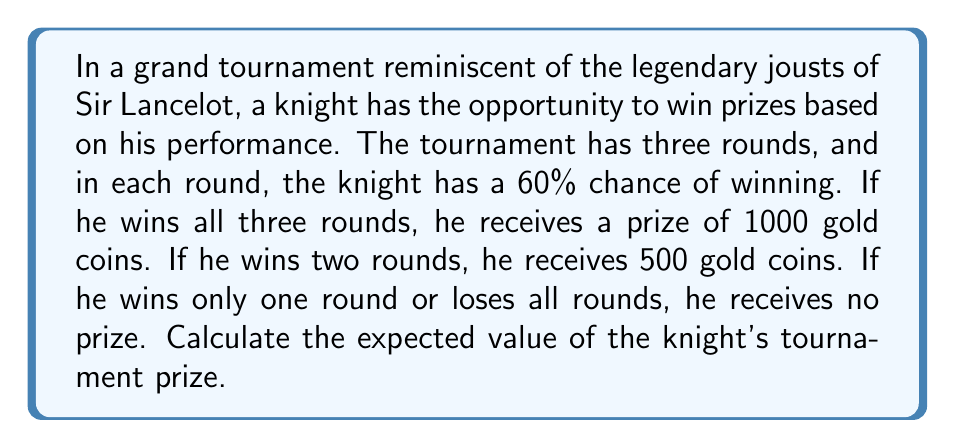Can you answer this question? To solve this problem, we need to follow these steps:

1) First, let's calculate the probabilities of each outcome:

   Win all 3 rounds: $P(3) = 0.6 \times 0.6 \times 0.6 = 0.216$
   Win exactly 2 rounds: $P(2) = \binom{3}{2} \times 0.6^2 \times 0.4 = 3 \times 0.6^2 \times 0.4 = 0.432$
   Win 1 or 0 rounds: $P(1 \text{ or } 0) = 1 - P(3) - P(2) = 1 - 0.216 - 0.432 = 0.352$

2) Now, let's assign the prizes to each outcome:

   Win all 3 rounds: 1000 gold coins
   Win exactly 2 rounds: 500 gold coins
   Win 1 or 0 rounds: 0 gold coins

3) The expected value is calculated by multiplying each possible outcome by its probability and then summing these products:

   $$E = (1000 \times 0.216) + (500 \times 0.432) + (0 \times 0.352)$$

4) Let's calculate each term:

   $1000 \times 0.216 = 216$
   $500 \times 0.432 = 216$
   $0 \times 0.352 = 0$

5) Now, we sum these values:

   $$E = 216 + 216 + 0 = 432$$

Therefore, the expected value of the knight's tournament prize is 432 gold coins.
Answer: The expected value of the knight's tournament prize is 432 gold coins. 